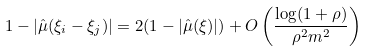Convert formula to latex. <formula><loc_0><loc_0><loc_500><loc_500>1 - \left | \hat { \mu } ( \xi _ { i } - \xi _ { j } ) \right | = 2 ( 1 - | \hat { \mu } ( \xi ) | ) + O \left ( \frac { \log ( 1 + \rho ) } { \rho ^ { 2 } m ^ { 2 } } \right )</formula> 